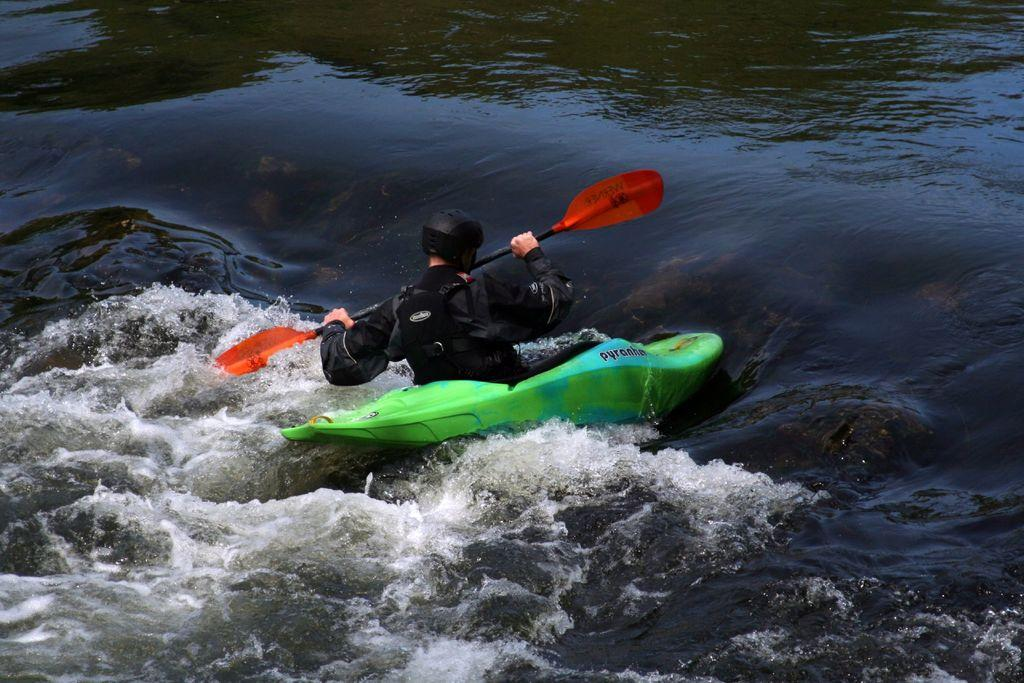Who is in the image? There is a person in the image. What is the person doing in the image? The person is in a boat and riding it. What is the person holding in the image? The person is holding a stick. What is the setting of the image? There is a river in the image. What is the cause of the volleyball in the image? There is no volleyball present in the image. What is the end result of the person's actions in the image? The end result of the person's actions in the image is not explicitly stated, as we only know that they are riding a boat and holding a stick. 